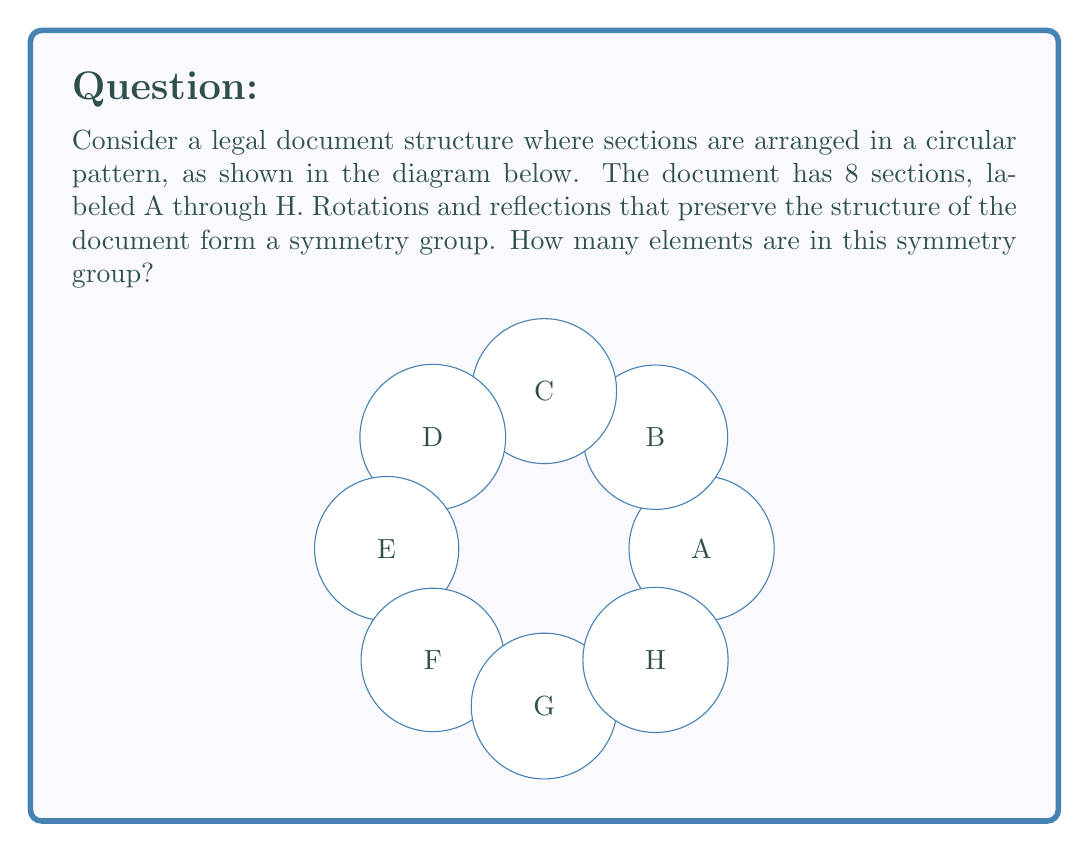Can you solve this math problem? To determine the number of elements in the symmetry group of this legal document structure, we need to consider both rotations and reflections:

1. Rotations:
   - There are 8 possible rotations (including the identity rotation):
     0°, 45°, 90°, 135°, 180°, 225°, 270°, and 315°

2. Reflections:
   - There are 8 lines of reflection:
     4 passing through opposite vertices (A-E, B-F, C-G, D-H)
     4 passing through the midpoints of opposite sides

3. Total number of symmetries:
   - The total number of elements in the symmetry group is the sum of rotations and reflections:
     $$8 \text{ rotations} + 8 \text{ reflections} = 16 \text{ elements}$$

This symmetry group is known as the dihedral group $D_8$, which has order 16.

In group theory terms, we can express this as:
$$|D_8| = 2n = 2 \cdot 8 = 16$$

where $n$ is the number of sides in the regular polygon (in this case, an octagon).
Answer: 16 